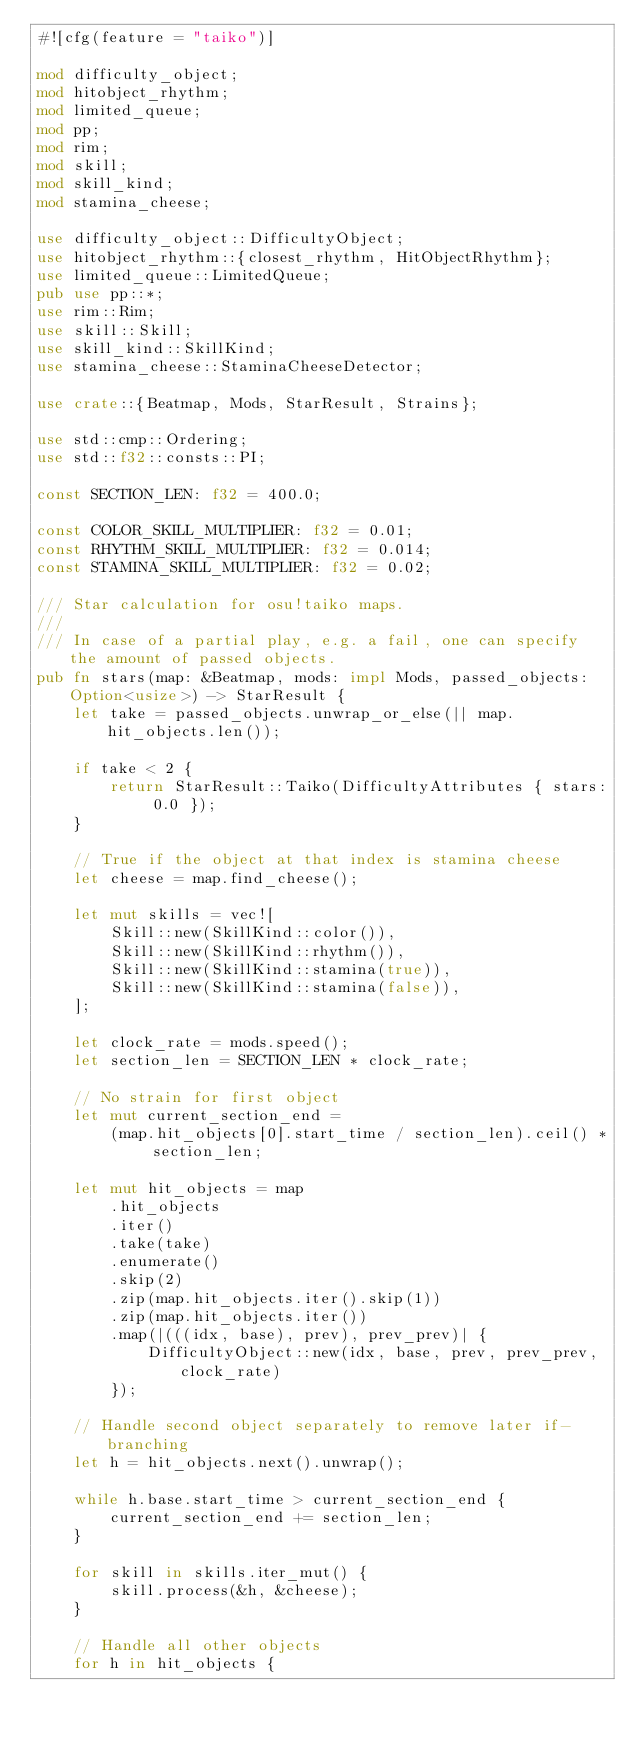<code> <loc_0><loc_0><loc_500><loc_500><_Rust_>#![cfg(feature = "taiko")]

mod difficulty_object;
mod hitobject_rhythm;
mod limited_queue;
mod pp;
mod rim;
mod skill;
mod skill_kind;
mod stamina_cheese;

use difficulty_object::DifficultyObject;
use hitobject_rhythm::{closest_rhythm, HitObjectRhythm};
use limited_queue::LimitedQueue;
pub use pp::*;
use rim::Rim;
use skill::Skill;
use skill_kind::SkillKind;
use stamina_cheese::StaminaCheeseDetector;

use crate::{Beatmap, Mods, StarResult, Strains};

use std::cmp::Ordering;
use std::f32::consts::PI;

const SECTION_LEN: f32 = 400.0;

const COLOR_SKILL_MULTIPLIER: f32 = 0.01;
const RHYTHM_SKILL_MULTIPLIER: f32 = 0.014;
const STAMINA_SKILL_MULTIPLIER: f32 = 0.02;

/// Star calculation for osu!taiko maps.
///
/// In case of a partial play, e.g. a fail, one can specify the amount of passed objects.
pub fn stars(map: &Beatmap, mods: impl Mods, passed_objects: Option<usize>) -> StarResult {
    let take = passed_objects.unwrap_or_else(|| map.hit_objects.len());

    if take < 2 {
        return StarResult::Taiko(DifficultyAttributes { stars: 0.0 });
    }

    // True if the object at that index is stamina cheese
    let cheese = map.find_cheese();

    let mut skills = vec![
        Skill::new(SkillKind::color()),
        Skill::new(SkillKind::rhythm()),
        Skill::new(SkillKind::stamina(true)),
        Skill::new(SkillKind::stamina(false)),
    ];

    let clock_rate = mods.speed();
    let section_len = SECTION_LEN * clock_rate;

    // No strain for first object
    let mut current_section_end =
        (map.hit_objects[0].start_time / section_len).ceil() * section_len;

    let mut hit_objects = map
        .hit_objects
        .iter()
        .take(take)
        .enumerate()
        .skip(2)
        .zip(map.hit_objects.iter().skip(1))
        .zip(map.hit_objects.iter())
        .map(|(((idx, base), prev), prev_prev)| {
            DifficultyObject::new(idx, base, prev, prev_prev, clock_rate)
        });

    // Handle second object separately to remove later if-branching
    let h = hit_objects.next().unwrap();

    while h.base.start_time > current_section_end {
        current_section_end += section_len;
    }

    for skill in skills.iter_mut() {
        skill.process(&h, &cheese);
    }

    // Handle all other objects
    for h in hit_objects {</code> 